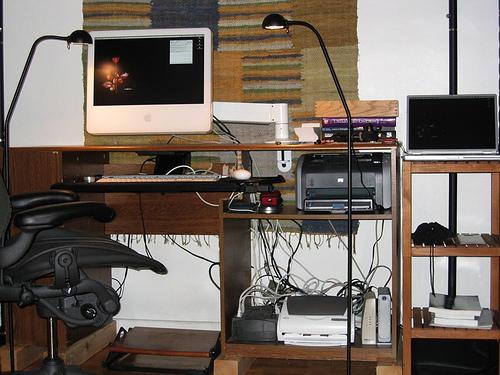How many printers?
Quick response, please. 2. Is there a printer on the desk?
Answer briefly. Yes. Who made the monitor to the left?
Short answer required. Apple. 